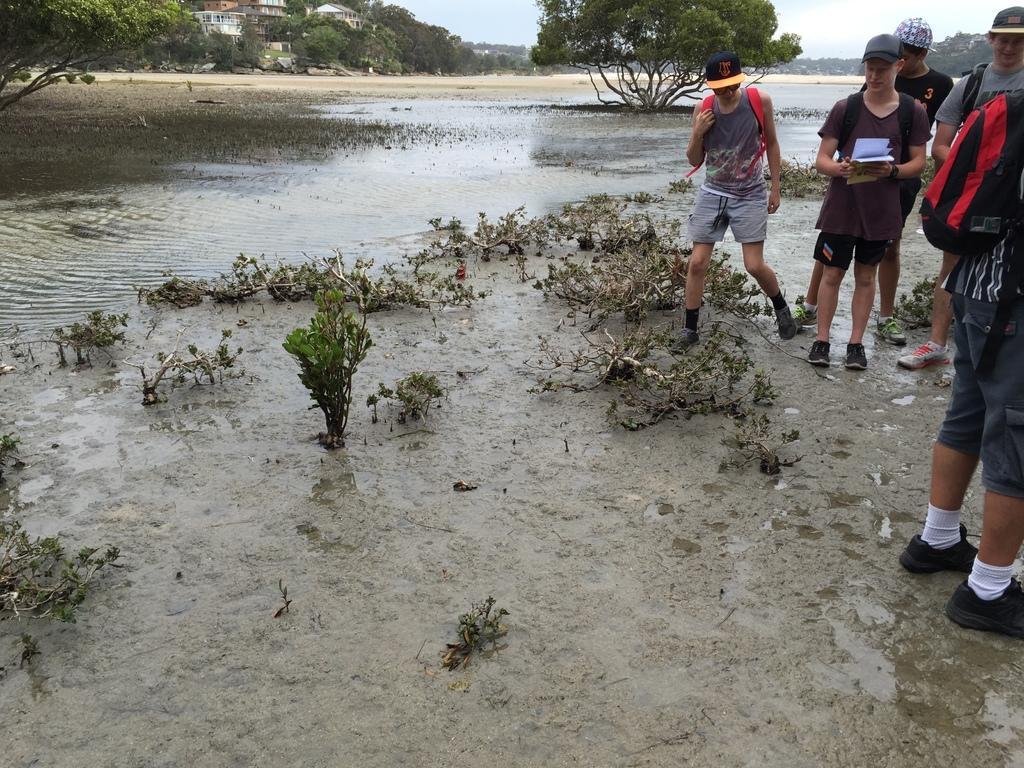Could you give a brief overview of what you see in this image? This image is taken outdoors. At the bottom of the image there is a ground. At the top of the image there is a sky with clouds. In the background there are many trees and plants and there are a few houses. In the middle of the image there are a few plants on the ground and there is a pond with water. On the left side of the image a few people are walking on the ground and a man is walking on the ground. 